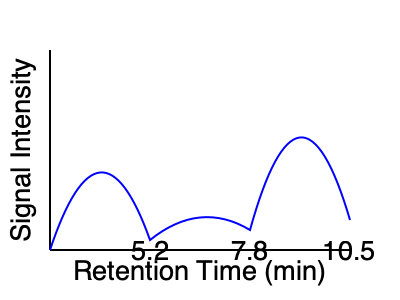In the chromatogram shown, three peaks are observed at retention times of 5.2, 7.8, and 10.5 minutes. If the peak at 7.8 minutes corresponds to the drug of interest, and its area is 85% of the total peak area, what conclusion can be drawn about the drug's purity? Assume that all impurities are detected and that peak area is directly proportional to concentration. To determine the drug's purity, we need to follow these steps:

1. Understand the relationship between peak area and concentration:
   - In chromatography, peak area is directly proportional to the concentration of the compound.

2. Interpret the given information:
   - The peak at 7.8 minutes corresponds to the drug of interest.
   - This peak's area is 85% of the total peak area.

3. Calculate the purity:
   - Since the drug's peak area is 85% of the total, this directly translates to 85% purity.
   - The remaining 15% represents impurities (the other two peaks).

4. Consider the assumptions:
   - We assume all impurities are detected.
   - We assume the detector response is the same for all compounds (linear and equal response factors).

5. Apply pharmaceutical industry standards:
   - In the pharmaceutical industry, high purity is typically required for drug substances.
   - Generally, a purity of ≥98% is often considered high purity for drug substances.

6. Draw a conclusion:
   - At 85% purity, this drug sample would not meet typical pharmaceutical grade standards.
   - Further purification or process optimization would be necessary to improve the purity.

Therefore, based on the chromatogram and the given information, we can conclude that the drug has a purity of 85%, which is below typical pharmaceutical grade standards and would require further purification.
Answer: The drug has 85% purity, which is below pharmaceutical grade standards and requires further purification. 